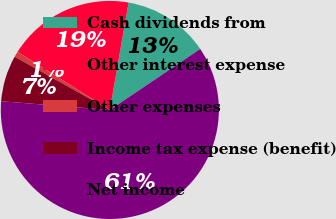Convert chart to OTSL. <chart><loc_0><loc_0><loc_500><loc_500><pie_chart><fcel>Cash dividends from<fcel>Other interest expense<fcel>Other expenses<fcel>Income tax expense (benefit)<fcel>Net income<nl><fcel>12.81%<fcel>18.8%<fcel>0.84%<fcel>6.83%<fcel>60.72%<nl></chart> 